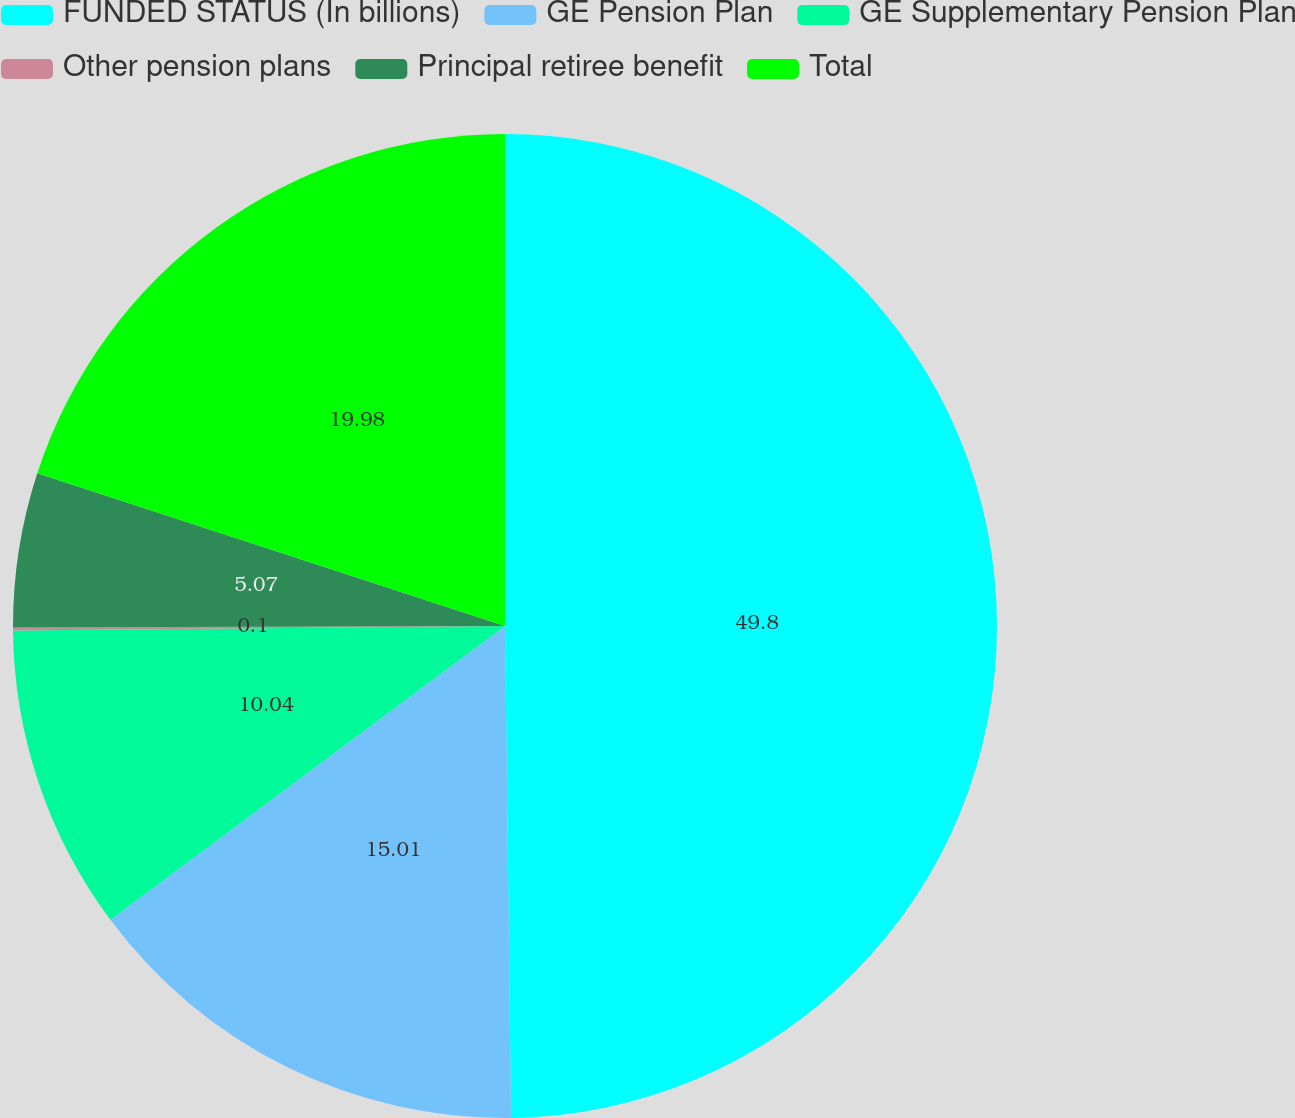<chart> <loc_0><loc_0><loc_500><loc_500><pie_chart><fcel>FUNDED STATUS (In billions)<fcel>GE Pension Plan<fcel>GE Supplementary Pension Plan<fcel>Other pension plans<fcel>Principal retiree benefit<fcel>Total<nl><fcel>49.81%<fcel>15.01%<fcel>10.04%<fcel>0.1%<fcel>5.07%<fcel>19.98%<nl></chart> 